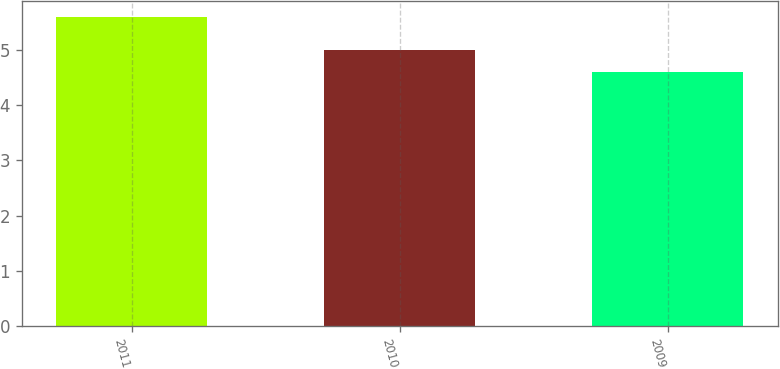Convert chart to OTSL. <chart><loc_0><loc_0><loc_500><loc_500><bar_chart><fcel>2011<fcel>2010<fcel>2009<nl><fcel>5.6<fcel>5<fcel>4.6<nl></chart> 